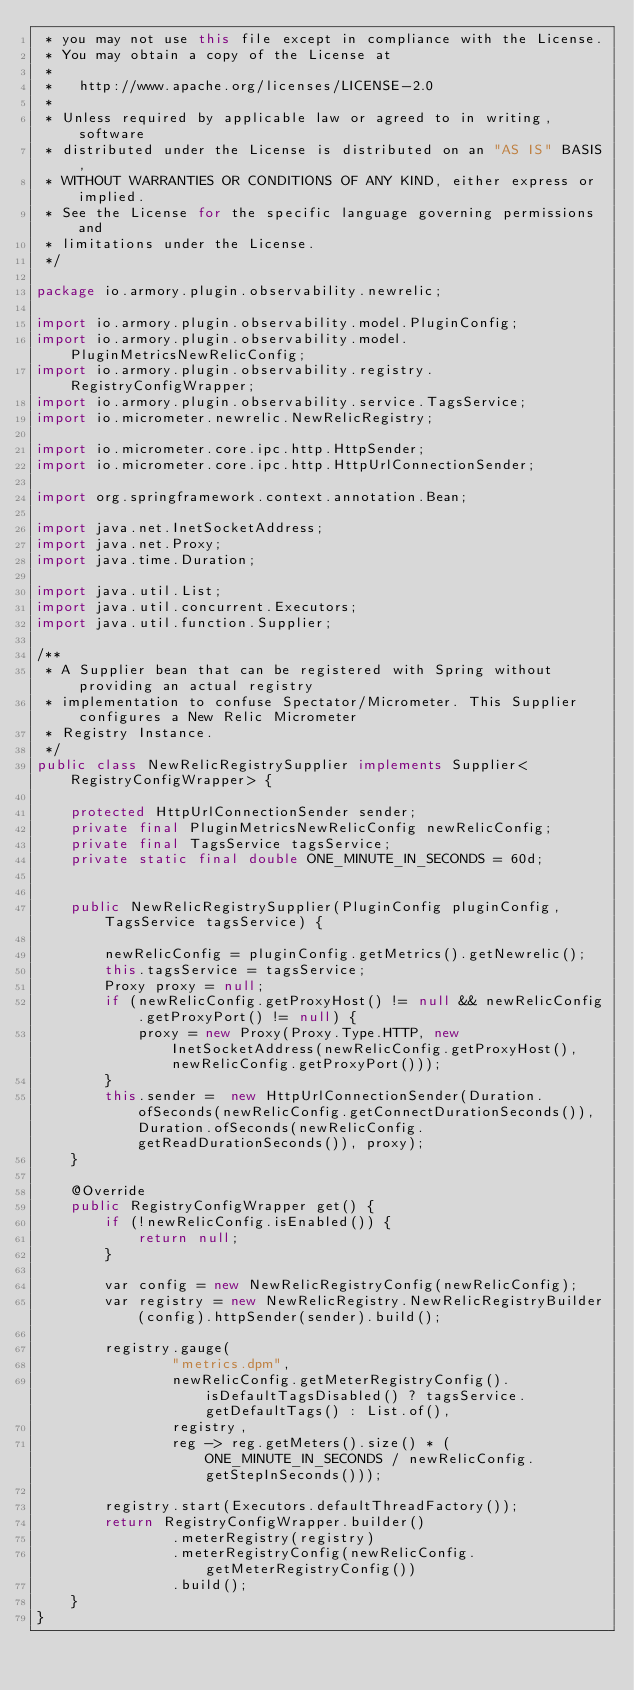Convert code to text. <code><loc_0><loc_0><loc_500><loc_500><_Java_> * you may not use this file except in compliance with the License.
 * You may obtain a copy of the License at
 *
 *   http://www.apache.org/licenses/LICENSE-2.0
 *
 * Unless required by applicable law or agreed to in writing, software
 * distributed under the License is distributed on an "AS IS" BASIS,
 * WITHOUT WARRANTIES OR CONDITIONS OF ANY KIND, either express or implied.
 * See the License for the specific language governing permissions and
 * limitations under the License.
 */

package io.armory.plugin.observability.newrelic;

import io.armory.plugin.observability.model.PluginConfig;
import io.armory.plugin.observability.model.PluginMetricsNewRelicConfig;
import io.armory.plugin.observability.registry.RegistryConfigWrapper;
import io.armory.plugin.observability.service.TagsService;
import io.micrometer.newrelic.NewRelicRegistry;

import io.micrometer.core.ipc.http.HttpSender;
import io.micrometer.core.ipc.http.HttpUrlConnectionSender;

import org.springframework.context.annotation.Bean;

import java.net.InetSocketAddress;
import java.net.Proxy;
import java.time.Duration;

import java.util.List;
import java.util.concurrent.Executors;
import java.util.function.Supplier;

/**
 * A Supplier bean that can be registered with Spring without providing an actual registry
 * implementation to confuse Spectator/Micrometer. This Supplier configures a New Relic Micrometer
 * Registry Instance.
 */
public class NewRelicRegistrySupplier implements Supplier<RegistryConfigWrapper> {

    protected HttpUrlConnectionSender sender;
    private final PluginMetricsNewRelicConfig newRelicConfig;
    private final TagsService tagsService;
    private static final double ONE_MINUTE_IN_SECONDS = 60d;


    public NewRelicRegistrySupplier(PluginConfig pluginConfig, TagsService tagsService) {

        newRelicConfig = pluginConfig.getMetrics().getNewrelic();
        this.tagsService = tagsService;
        Proxy proxy = null;
        if (newRelicConfig.getProxyHost() != null && newRelicConfig.getProxyPort() != null) {
            proxy = new Proxy(Proxy.Type.HTTP, new InetSocketAddress(newRelicConfig.getProxyHost(), newRelicConfig.getProxyPort()));
        }
        this.sender =  new HttpUrlConnectionSender(Duration.ofSeconds(newRelicConfig.getConnectDurationSeconds()),Duration.ofSeconds(newRelicConfig.getReadDurationSeconds()), proxy);
    }

    @Override
    public RegistryConfigWrapper get() {
        if (!newRelicConfig.isEnabled()) {
            return null;
        }

        var config = new NewRelicRegistryConfig(newRelicConfig);
        var registry = new NewRelicRegistry.NewRelicRegistryBuilder(config).httpSender(sender).build();

        registry.gauge(
                "metrics.dpm",
                newRelicConfig.getMeterRegistryConfig().isDefaultTagsDisabled() ? tagsService.getDefaultTags() : List.of(),
                registry,
                reg -> reg.getMeters().size() * (ONE_MINUTE_IN_SECONDS / newRelicConfig.getStepInSeconds()));

        registry.start(Executors.defaultThreadFactory());
        return RegistryConfigWrapper.builder()
                .meterRegistry(registry)
                .meterRegistryConfig(newRelicConfig.getMeterRegistryConfig())
                .build();
    }
}
</code> 